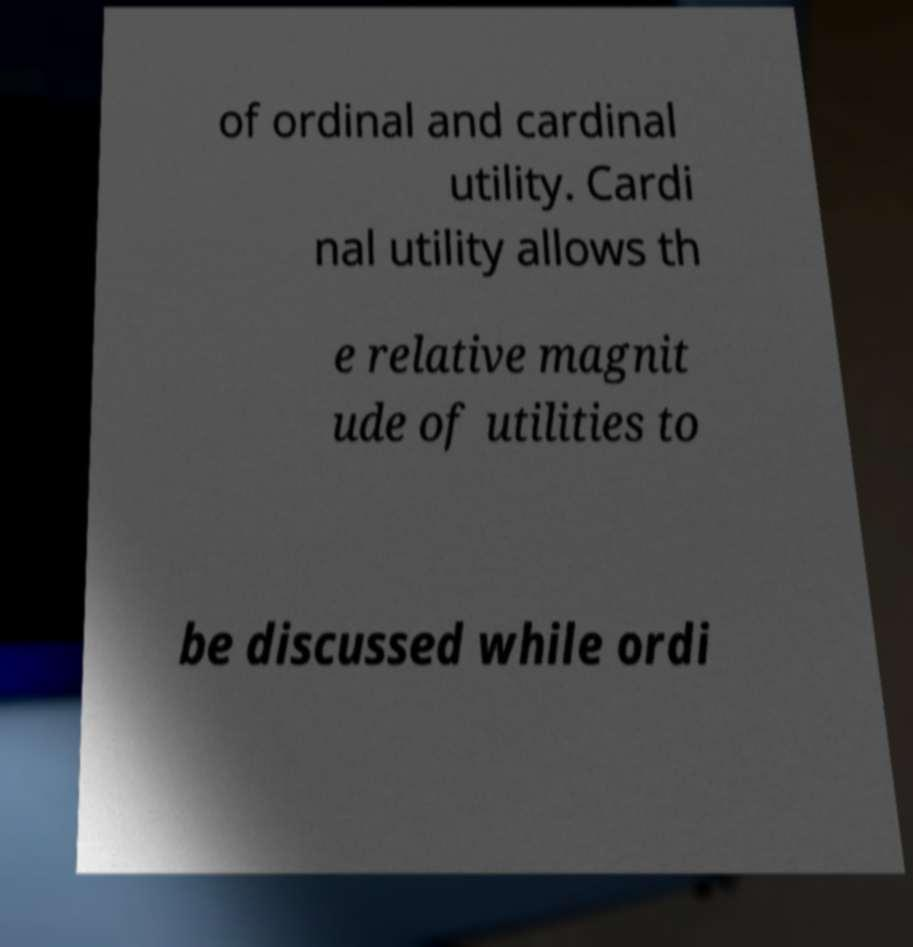What messages or text are displayed in this image? I need them in a readable, typed format. of ordinal and cardinal utility. Cardi nal utility allows th e relative magnit ude of utilities to be discussed while ordi 